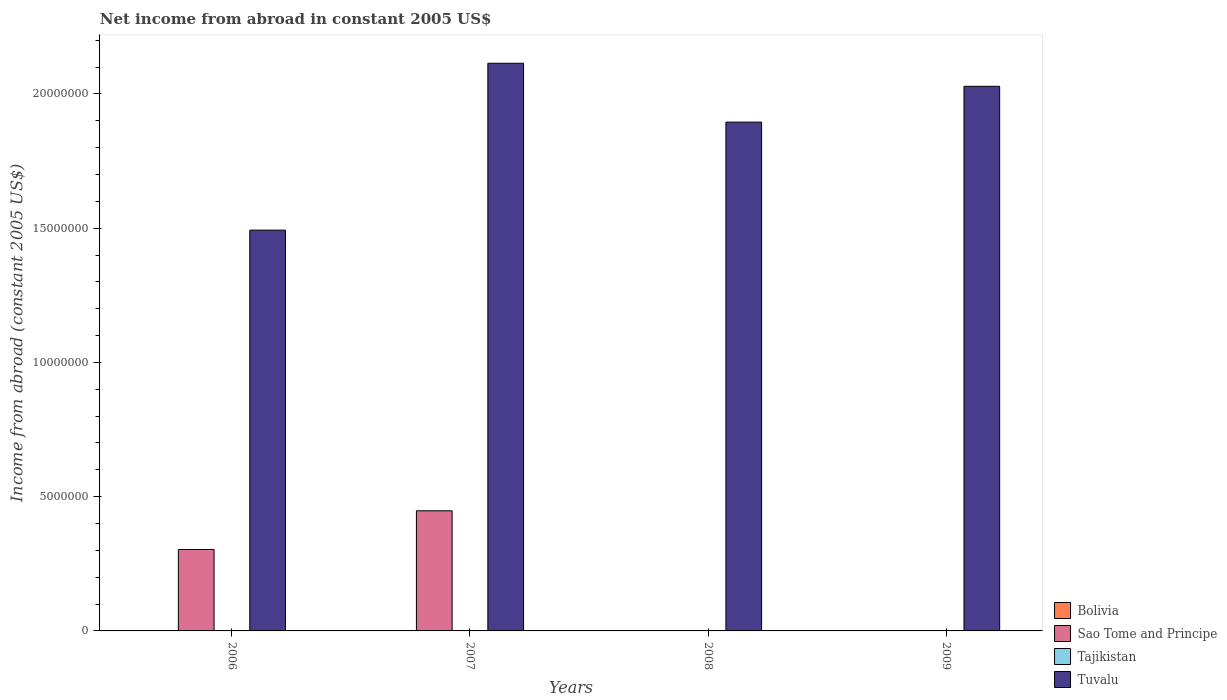How many different coloured bars are there?
Your answer should be compact. 2. Are the number of bars per tick equal to the number of legend labels?
Provide a succinct answer. No. Are the number of bars on each tick of the X-axis equal?
Provide a short and direct response. No. What is the net income from abroad in Bolivia in 2008?
Your answer should be compact. 0. Across all years, what is the maximum net income from abroad in Tuvalu?
Your answer should be very brief. 2.11e+07. What is the total net income from abroad in Sao Tome and Principe in the graph?
Give a very brief answer. 7.51e+06. What is the difference between the net income from abroad in Tuvalu in 2007 and that in 2008?
Keep it short and to the point. 2.19e+06. What is the average net income from abroad in Tuvalu per year?
Give a very brief answer. 1.88e+07. In the year 2006, what is the difference between the net income from abroad in Tuvalu and net income from abroad in Sao Tome and Principe?
Provide a short and direct response. 1.19e+07. In how many years, is the net income from abroad in Tuvalu greater than 8000000 US$?
Offer a very short reply. 4. What is the ratio of the net income from abroad in Tuvalu in 2006 to that in 2007?
Your answer should be very brief. 0.71. Is the net income from abroad in Tuvalu in 2006 less than that in 2008?
Your answer should be very brief. Yes. What is the difference between the highest and the second highest net income from abroad in Tuvalu?
Provide a succinct answer. 8.59e+05. What is the difference between the highest and the lowest net income from abroad in Tuvalu?
Offer a terse response. 6.22e+06. In how many years, is the net income from abroad in Bolivia greater than the average net income from abroad in Bolivia taken over all years?
Your answer should be compact. 0. Is it the case that in every year, the sum of the net income from abroad in Bolivia and net income from abroad in Tuvalu is greater than the sum of net income from abroad in Sao Tome and Principe and net income from abroad in Tajikistan?
Your answer should be compact. Yes. Is it the case that in every year, the sum of the net income from abroad in Tajikistan and net income from abroad in Bolivia is greater than the net income from abroad in Sao Tome and Principe?
Make the answer very short. No. How many bars are there?
Provide a short and direct response. 6. How many years are there in the graph?
Give a very brief answer. 4. Are the values on the major ticks of Y-axis written in scientific E-notation?
Make the answer very short. No. Does the graph contain grids?
Provide a short and direct response. No. How many legend labels are there?
Make the answer very short. 4. How are the legend labels stacked?
Your answer should be very brief. Vertical. What is the title of the graph?
Offer a very short reply. Net income from abroad in constant 2005 US$. Does "Somalia" appear as one of the legend labels in the graph?
Provide a succinct answer. No. What is the label or title of the X-axis?
Give a very brief answer. Years. What is the label or title of the Y-axis?
Provide a short and direct response. Income from abroad (constant 2005 US$). What is the Income from abroad (constant 2005 US$) of Bolivia in 2006?
Make the answer very short. 0. What is the Income from abroad (constant 2005 US$) of Sao Tome and Principe in 2006?
Your answer should be very brief. 3.03e+06. What is the Income from abroad (constant 2005 US$) in Tuvalu in 2006?
Your answer should be compact. 1.49e+07. What is the Income from abroad (constant 2005 US$) in Sao Tome and Principe in 2007?
Your answer should be very brief. 4.47e+06. What is the Income from abroad (constant 2005 US$) in Tuvalu in 2007?
Ensure brevity in your answer.  2.11e+07. What is the Income from abroad (constant 2005 US$) in Sao Tome and Principe in 2008?
Your response must be concise. 0. What is the Income from abroad (constant 2005 US$) in Tajikistan in 2008?
Your answer should be compact. 0. What is the Income from abroad (constant 2005 US$) of Tuvalu in 2008?
Your response must be concise. 1.90e+07. What is the Income from abroad (constant 2005 US$) of Tuvalu in 2009?
Provide a succinct answer. 2.03e+07. Across all years, what is the maximum Income from abroad (constant 2005 US$) of Sao Tome and Principe?
Offer a very short reply. 4.47e+06. Across all years, what is the maximum Income from abroad (constant 2005 US$) of Tuvalu?
Give a very brief answer. 2.11e+07. Across all years, what is the minimum Income from abroad (constant 2005 US$) of Sao Tome and Principe?
Keep it short and to the point. 0. Across all years, what is the minimum Income from abroad (constant 2005 US$) in Tuvalu?
Your answer should be very brief. 1.49e+07. What is the total Income from abroad (constant 2005 US$) of Sao Tome and Principe in the graph?
Offer a very short reply. 7.51e+06. What is the total Income from abroad (constant 2005 US$) in Tuvalu in the graph?
Give a very brief answer. 7.53e+07. What is the difference between the Income from abroad (constant 2005 US$) in Sao Tome and Principe in 2006 and that in 2007?
Provide a succinct answer. -1.44e+06. What is the difference between the Income from abroad (constant 2005 US$) in Tuvalu in 2006 and that in 2007?
Your answer should be very brief. -6.22e+06. What is the difference between the Income from abroad (constant 2005 US$) of Tuvalu in 2006 and that in 2008?
Offer a terse response. -4.02e+06. What is the difference between the Income from abroad (constant 2005 US$) in Tuvalu in 2006 and that in 2009?
Your answer should be very brief. -5.36e+06. What is the difference between the Income from abroad (constant 2005 US$) of Tuvalu in 2007 and that in 2008?
Your answer should be compact. 2.19e+06. What is the difference between the Income from abroad (constant 2005 US$) of Tuvalu in 2007 and that in 2009?
Provide a succinct answer. 8.59e+05. What is the difference between the Income from abroad (constant 2005 US$) of Tuvalu in 2008 and that in 2009?
Your answer should be compact. -1.33e+06. What is the difference between the Income from abroad (constant 2005 US$) of Sao Tome and Principe in 2006 and the Income from abroad (constant 2005 US$) of Tuvalu in 2007?
Provide a succinct answer. -1.81e+07. What is the difference between the Income from abroad (constant 2005 US$) of Sao Tome and Principe in 2006 and the Income from abroad (constant 2005 US$) of Tuvalu in 2008?
Your answer should be compact. -1.59e+07. What is the difference between the Income from abroad (constant 2005 US$) in Sao Tome and Principe in 2006 and the Income from abroad (constant 2005 US$) in Tuvalu in 2009?
Ensure brevity in your answer.  -1.73e+07. What is the difference between the Income from abroad (constant 2005 US$) of Sao Tome and Principe in 2007 and the Income from abroad (constant 2005 US$) of Tuvalu in 2008?
Give a very brief answer. -1.45e+07. What is the difference between the Income from abroad (constant 2005 US$) in Sao Tome and Principe in 2007 and the Income from abroad (constant 2005 US$) in Tuvalu in 2009?
Offer a terse response. -1.58e+07. What is the average Income from abroad (constant 2005 US$) of Sao Tome and Principe per year?
Ensure brevity in your answer.  1.88e+06. What is the average Income from abroad (constant 2005 US$) in Tajikistan per year?
Provide a short and direct response. 0. What is the average Income from abroad (constant 2005 US$) in Tuvalu per year?
Your answer should be compact. 1.88e+07. In the year 2006, what is the difference between the Income from abroad (constant 2005 US$) in Sao Tome and Principe and Income from abroad (constant 2005 US$) in Tuvalu?
Your answer should be very brief. -1.19e+07. In the year 2007, what is the difference between the Income from abroad (constant 2005 US$) of Sao Tome and Principe and Income from abroad (constant 2005 US$) of Tuvalu?
Offer a terse response. -1.67e+07. What is the ratio of the Income from abroad (constant 2005 US$) in Sao Tome and Principe in 2006 to that in 2007?
Make the answer very short. 0.68. What is the ratio of the Income from abroad (constant 2005 US$) in Tuvalu in 2006 to that in 2007?
Keep it short and to the point. 0.71. What is the ratio of the Income from abroad (constant 2005 US$) of Tuvalu in 2006 to that in 2008?
Your response must be concise. 0.79. What is the ratio of the Income from abroad (constant 2005 US$) in Tuvalu in 2006 to that in 2009?
Provide a succinct answer. 0.74. What is the ratio of the Income from abroad (constant 2005 US$) of Tuvalu in 2007 to that in 2008?
Provide a short and direct response. 1.12. What is the ratio of the Income from abroad (constant 2005 US$) in Tuvalu in 2007 to that in 2009?
Your response must be concise. 1.04. What is the ratio of the Income from abroad (constant 2005 US$) in Tuvalu in 2008 to that in 2009?
Keep it short and to the point. 0.93. What is the difference between the highest and the second highest Income from abroad (constant 2005 US$) in Tuvalu?
Your answer should be very brief. 8.59e+05. What is the difference between the highest and the lowest Income from abroad (constant 2005 US$) in Sao Tome and Principe?
Provide a succinct answer. 4.47e+06. What is the difference between the highest and the lowest Income from abroad (constant 2005 US$) of Tuvalu?
Make the answer very short. 6.22e+06. 